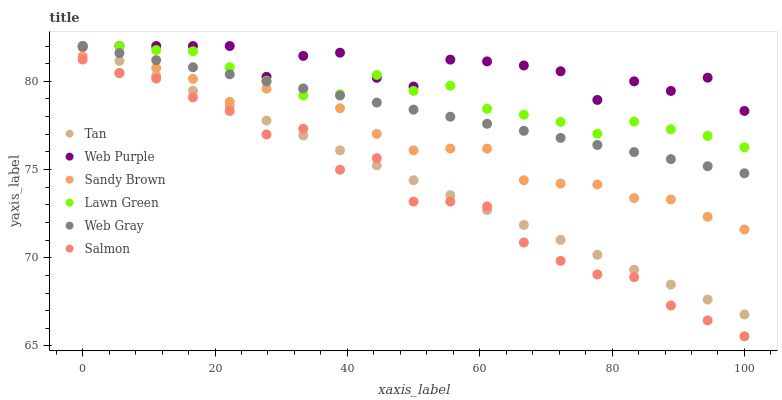Does Salmon have the minimum area under the curve?
Answer yes or no. Yes. Does Web Purple have the maximum area under the curve?
Answer yes or no. Yes. Does Web Gray have the minimum area under the curve?
Answer yes or no. No. Does Web Gray have the maximum area under the curve?
Answer yes or no. No. Is Web Gray the smoothest?
Answer yes or no. Yes. Is Web Purple the roughest?
Answer yes or no. Yes. Is Salmon the smoothest?
Answer yes or no. No. Is Salmon the roughest?
Answer yes or no. No. Does Salmon have the lowest value?
Answer yes or no. Yes. Does Web Gray have the lowest value?
Answer yes or no. No. Does Tan have the highest value?
Answer yes or no. Yes. Does Salmon have the highest value?
Answer yes or no. No. Is Salmon less than Sandy Brown?
Answer yes or no. Yes. Is Web Purple greater than Salmon?
Answer yes or no. Yes. Does Sandy Brown intersect Tan?
Answer yes or no. Yes. Is Sandy Brown less than Tan?
Answer yes or no. No. Is Sandy Brown greater than Tan?
Answer yes or no. No. Does Salmon intersect Sandy Brown?
Answer yes or no. No. 